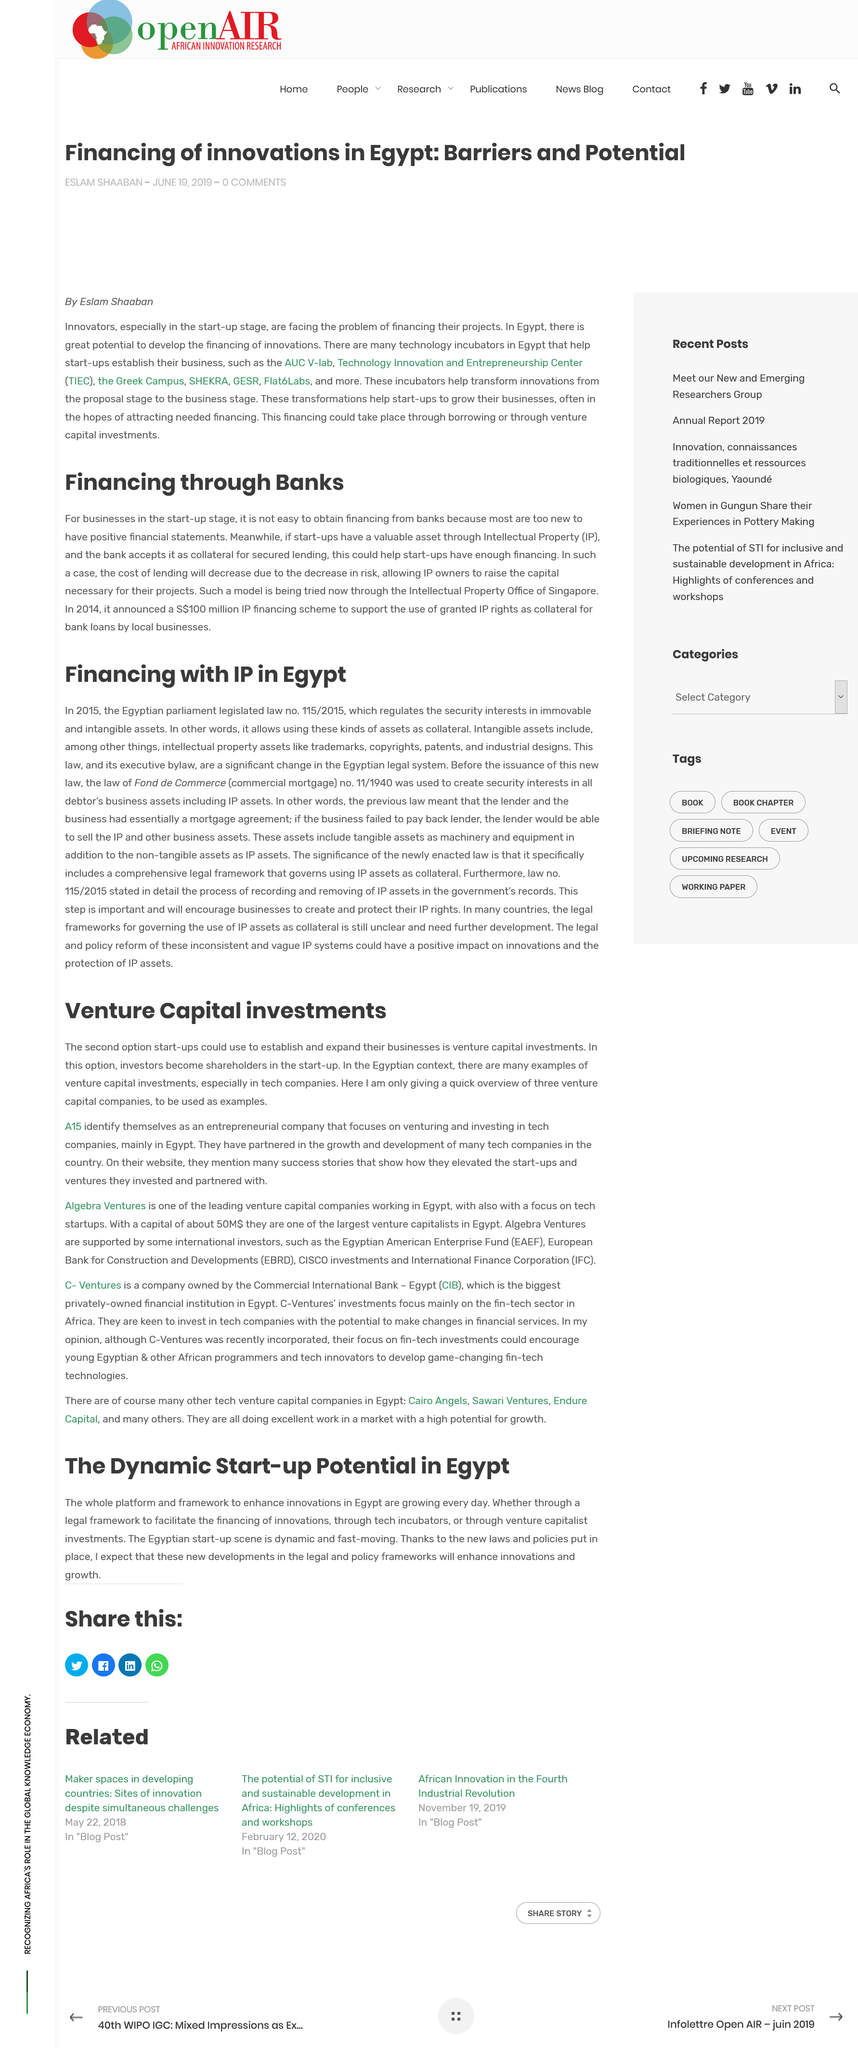Identify some key points in this picture. A15 is used by venture capital companies because it offers them a flexible and efficient way to manage their investments. One example of a venture capital company that uses A15 is XYZ Ventures. It is intended that 3 venture capital companies will be featured as examples in this report. The assertion that intellectual property (IP) can help start-ups decrease the cost of lending from banks is confirmed. The decrease in risk associated with IP can lead to a decrease in the cost of lending. The financing scheme was announced in Singapore in 2014. The model is currently being tested in Singapore. 